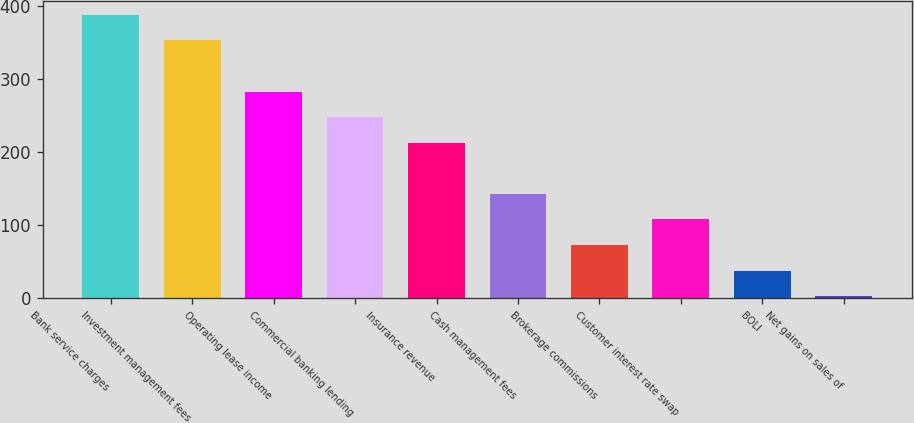Convert chart. <chart><loc_0><loc_0><loc_500><loc_500><bar_chart><fcel>Bank service charges<fcel>Investment management fees<fcel>Operating lease income<fcel>Commercial banking lending<fcel>Insurance revenue<fcel>Cash management fees<fcel>Brokerage commissions<fcel>Customer interest rate swap<fcel>BOLI<fcel>Net gains on sales of<nl><fcel>387.87<fcel>352.9<fcel>282.96<fcel>247.99<fcel>213.02<fcel>143.08<fcel>73.14<fcel>108.11<fcel>38.17<fcel>3.2<nl></chart> 